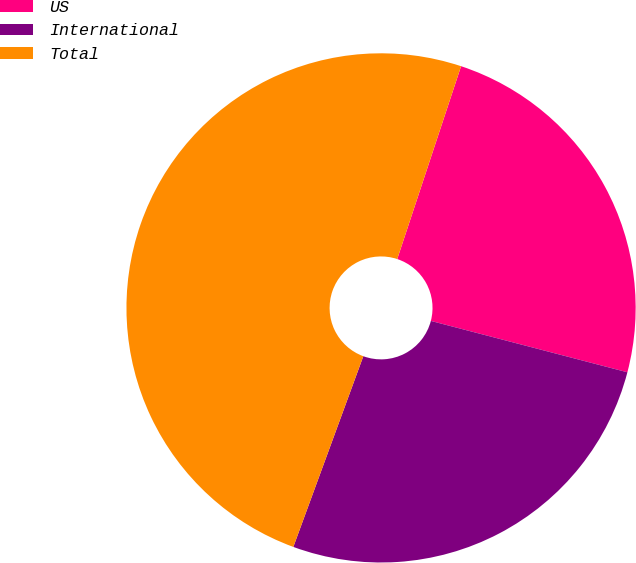Convert chart. <chart><loc_0><loc_0><loc_500><loc_500><pie_chart><fcel>US<fcel>International<fcel>Total<nl><fcel>23.98%<fcel>26.53%<fcel>49.49%<nl></chart> 